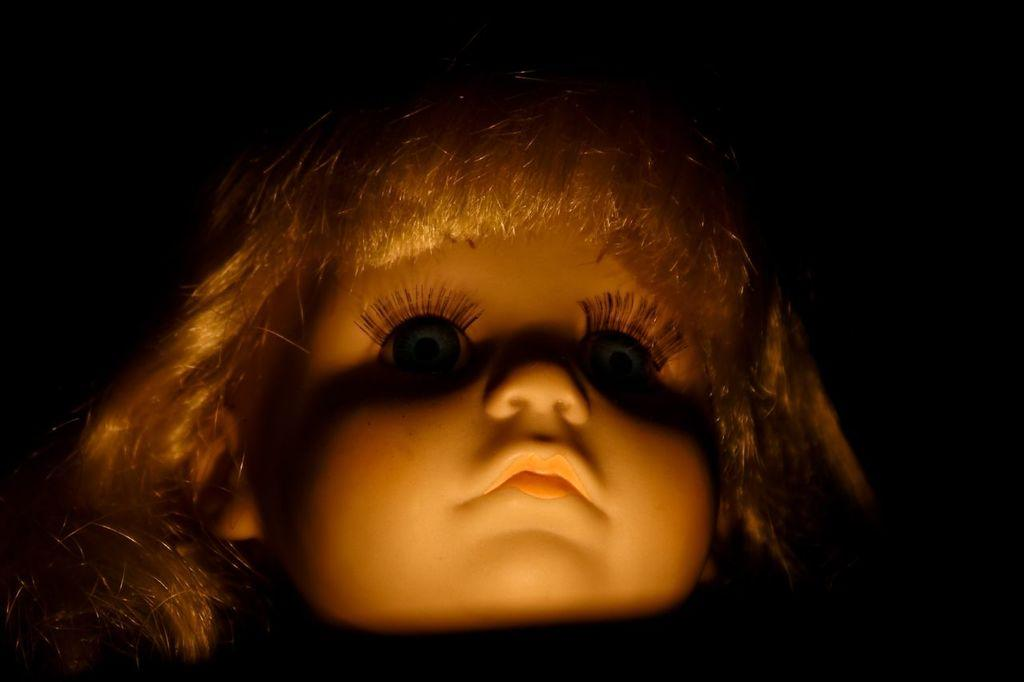What is the main subject of the image? There is a doll in the image. What color is the background of the image? The background of the image is black. Can you tell me how many cows are involved in the fight depicted in the image? There is no fight or cow present in the image; it features a doll with a black background. 